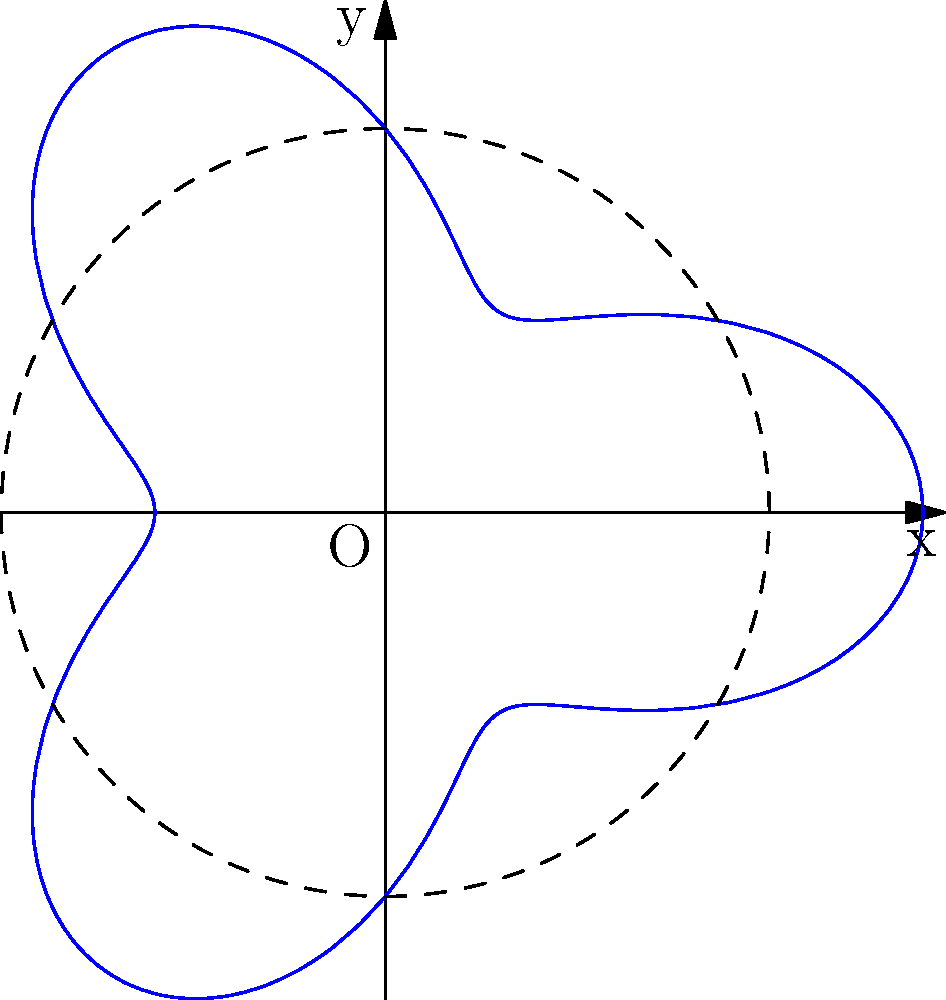As the stage lighting technician, you need to plot the beam of a spotlight that traces a unique pattern on the circular stage. The beam's distance from the center of the stage (in meters) is given by the polar equation $r = 5 + 2\cos(3\theta)$. What is the maximum distance the spotlight beam reaches from the center of the stage? To find the maximum distance of the spotlight beam from the center of the stage, we need to follow these steps:

1) The given equation is $r = 5 + 2\cos(3\theta)$.

2) The maximum value of $r$ will occur when $\cos(3\theta)$ is at its maximum.

3) We know that the maximum value of cosine is 1.

4) Therefore, the maximum value of $r$ will be when $2\cos(3\theta) = 2$.

5) Substituting this into our original equation:

   $r_{max} = 5 + 2 = 7$

6) This means the maximum distance the spotlight beam reaches from the center of the stage is 7 meters.

Note: The dashed circle in the diagram represents the base radius of 5 meters, and the blue curve shows how the beam's distance varies, reaching a maximum of 7 meters at certain points.
Answer: 7 meters 